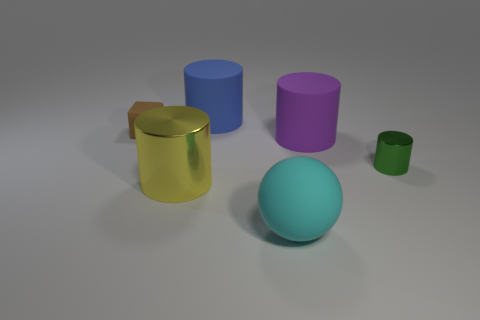Subtract all big shiny cylinders. How many cylinders are left? 3 Add 3 big yellow cylinders. How many objects exist? 9 Subtract all green cylinders. How many cylinders are left? 3 Subtract 1 spheres. How many spheres are left? 0 Subtract all cubes. How many objects are left? 5 Add 2 small rubber objects. How many small rubber objects are left? 3 Add 1 blue rubber cylinders. How many blue rubber cylinders exist? 2 Subtract 1 purple cylinders. How many objects are left? 5 Subtract all yellow cubes. Subtract all red balls. How many cubes are left? 1 Subtract all spheres. Subtract all red metal things. How many objects are left? 5 